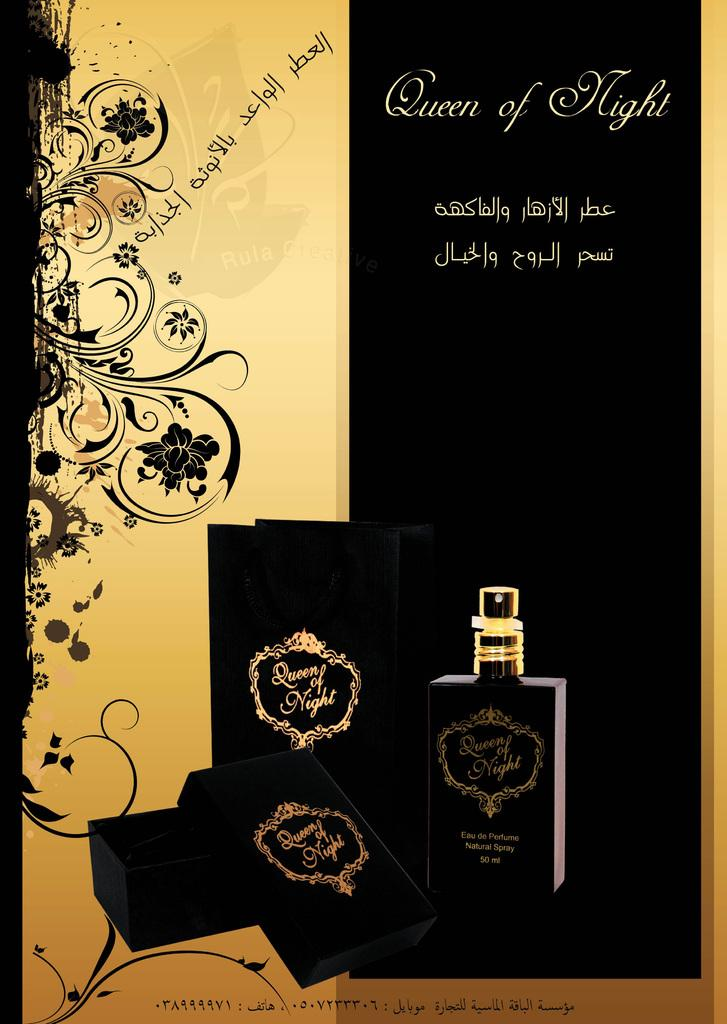Provide a one-sentence caption for the provided image. A magazine style ad for Queen of Night perfume. 